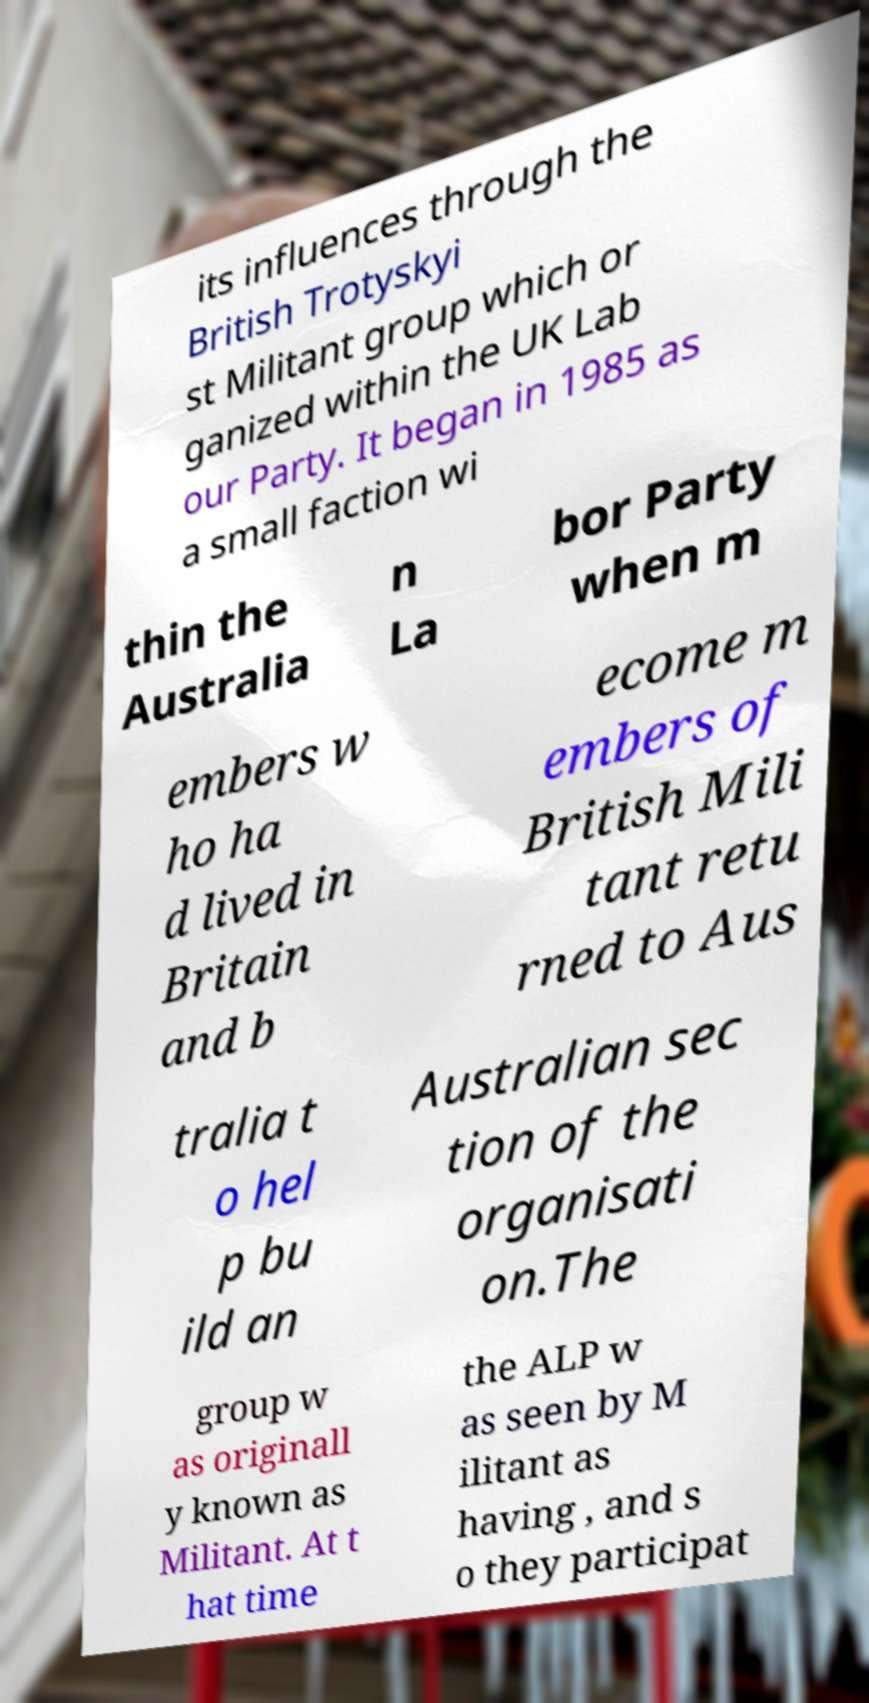I need the written content from this picture converted into text. Can you do that? its influences through the British Trotyskyi st Militant group which or ganized within the UK Lab our Party. It began in 1985 as a small faction wi thin the Australia n La bor Party when m embers w ho ha d lived in Britain and b ecome m embers of British Mili tant retu rned to Aus tralia t o hel p bu ild an Australian sec tion of the organisati on.The group w as originall y known as Militant. At t hat time the ALP w as seen by M ilitant as having , and s o they participat 